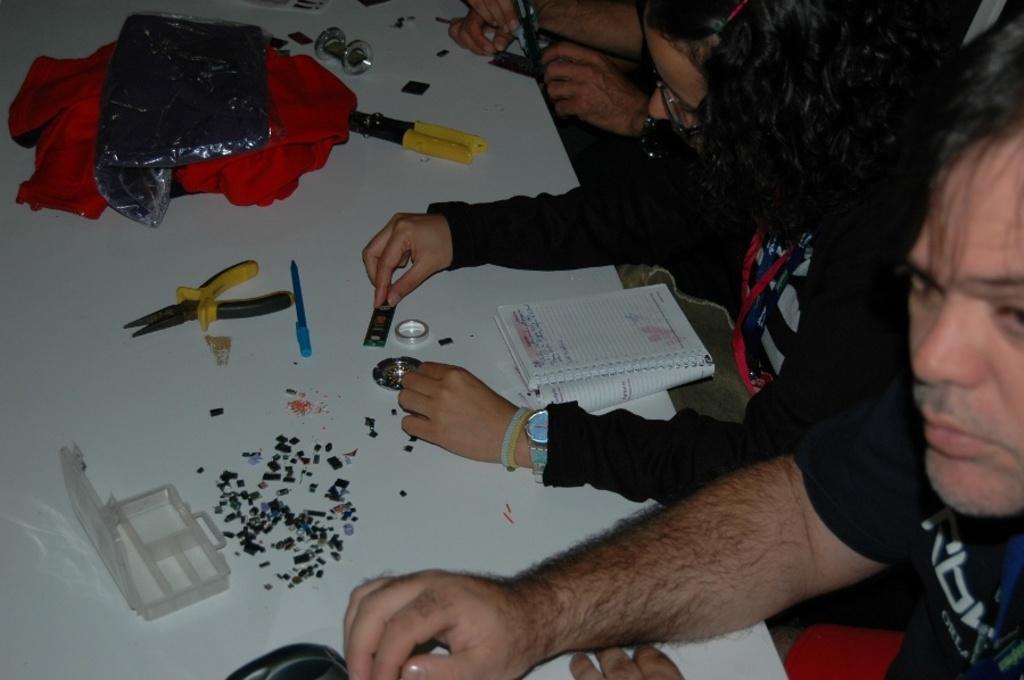How would you summarize this image in a sentence or two? In this image there are people and white table. On the table there is a book, box, tools, cloth and objects. Among them two people are holding objects. 